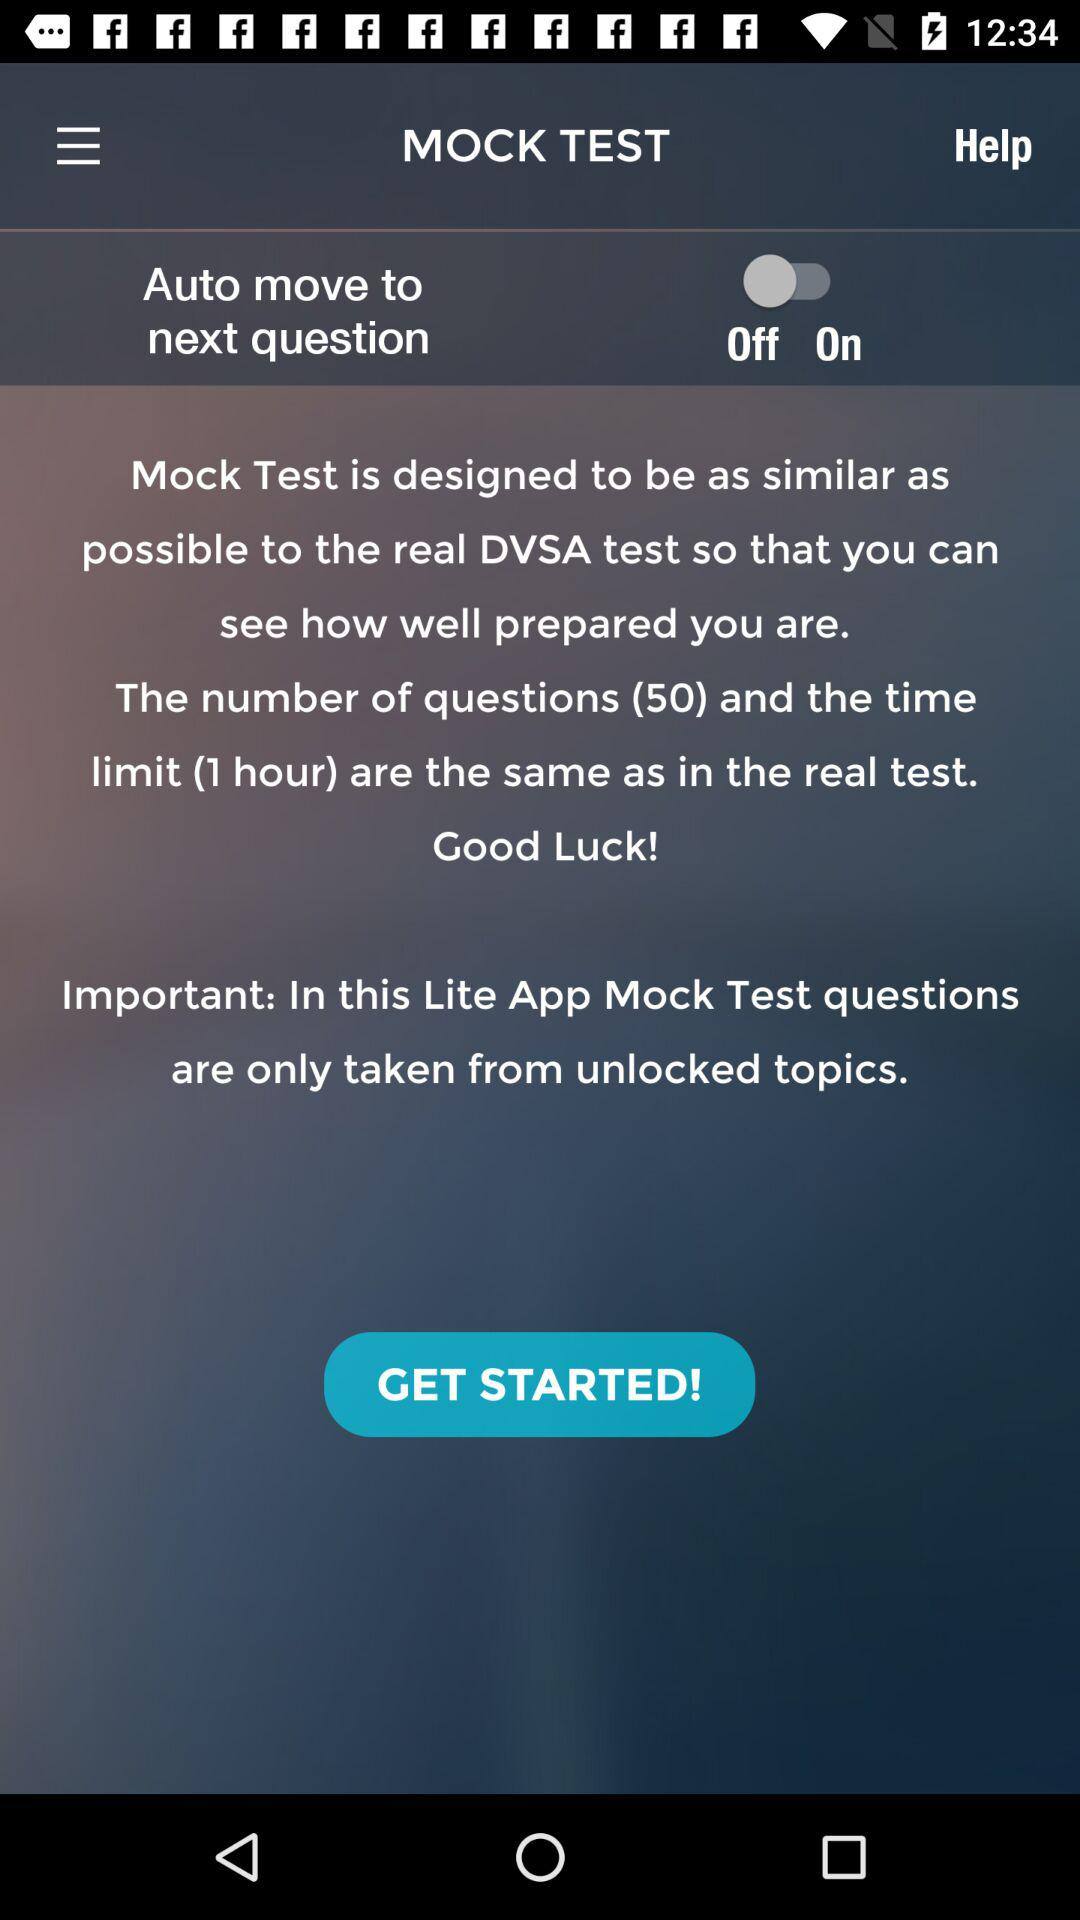Which topics are unlocked?
When the provided information is insufficient, respond with <no answer>. <no answer> 